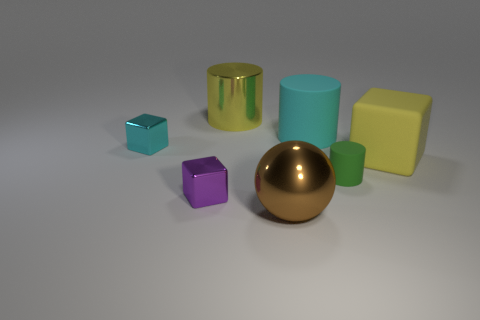How many other objects are the same material as the tiny purple block?
Make the answer very short. 3. Do the yellow object behind the small cyan block and the tiny cube in front of the yellow matte block have the same material?
Your answer should be compact. Yes. How many shiny things are behind the large yellow matte cube and in front of the purple metallic object?
Your response must be concise. 0. Are there any other matte things that have the same shape as the green rubber object?
Give a very brief answer. Yes. There is a cyan matte thing that is the same size as the yellow rubber block; what shape is it?
Provide a succinct answer. Cylinder. Are there an equal number of green cylinders that are in front of the tiny green cylinder and big spheres that are left of the small cyan metal thing?
Provide a succinct answer. Yes. How big is the cube on the right side of the purple thing to the left of the big cyan matte cylinder?
Your answer should be very brief. Large. Is there a cyan shiny thing that has the same size as the green rubber object?
Give a very brief answer. Yes. There is a big cylinder that is made of the same material as the large yellow block; what color is it?
Your answer should be compact. Cyan. Is the number of large blocks less than the number of metallic things?
Offer a very short reply. Yes. 